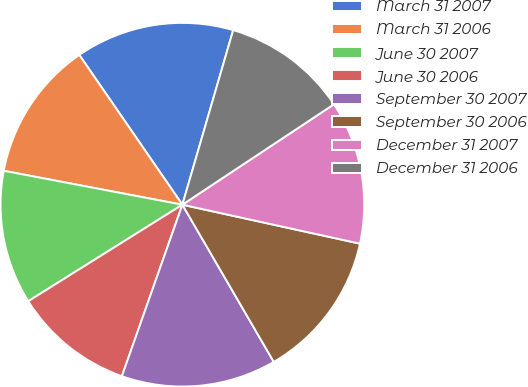<chart> <loc_0><loc_0><loc_500><loc_500><pie_chart><fcel>March 31 2007<fcel>March 31 2006<fcel>June 30 2007<fcel>June 30 2006<fcel>September 30 2007<fcel>September 30 2006<fcel>December 31 2007<fcel>December 31 2006<nl><fcel>14.1%<fcel>12.42%<fcel>11.89%<fcel>10.7%<fcel>13.78%<fcel>13.18%<fcel>12.75%<fcel>11.18%<nl></chart> 